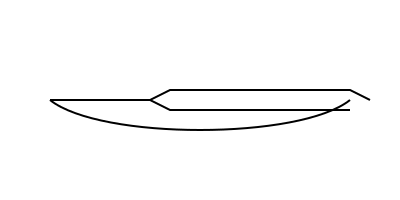As an expert in ancient battlefields, identify the weapon depicted in the silhouette above, commonly used by infantry in the Classical period. To identify this weapon, let's analyze its key features:

1. Long, slender shape: The silhouette shows an elongated object, indicating a polearm or similar long weapon.

2. Curved blade: The top line of the silhouette has a slight curve, suggesting a blade.

3. Spear-like structure: The overall shape resembles a spear, but with additional features.

4. Counterweight: The bottom line shows a curved section, likely representing a counterweight.

5. Historical context: The question mentions the Classical period, which typically refers to ancient Greek and Roman civilizations.

Given these characteristics, we can deduce that this weapon is a sarissa. The sarissa was a long pike used by the Macedonian phalanx infantry, famously employed by Philip II of Macedon and Alexander the Great. It was typically 4-6 meters long, with a small iron head and a bronze butt-spike that served as a counterweight.

The sarissa's length and use in tight formation made it a formidable weapon in ancient warfare, allowing the Macedonian phalanx to dominate battlefields during the Classical period.
Answer: Sarissa 